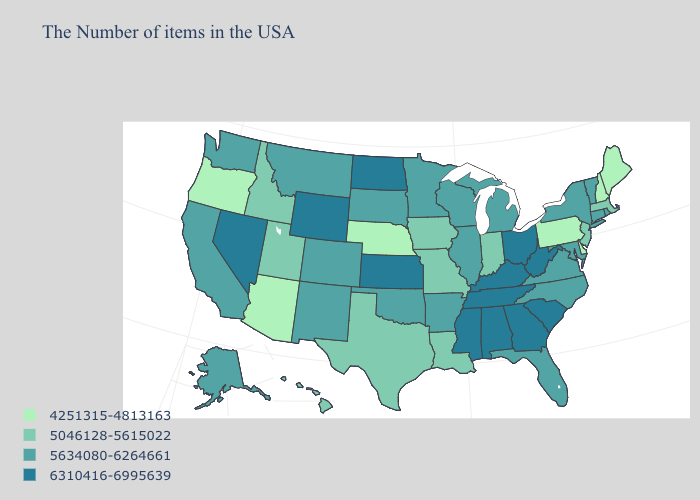Which states have the highest value in the USA?
Be succinct. South Carolina, West Virginia, Ohio, Georgia, Kentucky, Alabama, Tennessee, Mississippi, Kansas, North Dakota, Wyoming, Nevada. What is the value of Florida?
Quick response, please. 5634080-6264661. What is the highest value in the South ?
Keep it brief. 6310416-6995639. Among the states that border Arizona , does Nevada have the highest value?
Keep it brief. Yes. Name the states that have a value in the range 6310416-6995639?
Quick response, please. South Carolina, West Virginia, Ohio, Georgia, Kentucky, Alabama, Tennessee, Mississippi, Kansas, North Dakota, Wyoming, Nevada. How many symbols are there in the legend?
Answer briefly. 4. What is the value of Utah?
Give a very brief answer. 5046128-5615022. Does Vermont have the lowest value in the Northeast?
Be succinct. No. Which states have the highest value in the USA?
Be succinct. South Carolina, West Virginia, Ohio, Georgia, Kentucky, Alabama, Tennessee, Mississippi, Kansas, North Dakota, Wyoming, Nevada. Is the legend a continuous bar?
Quick response, please. No. What is the value of Illinois?
Keep it brief. 5634080-6264661. What is the highest value in the USA?
Keep it brief. 6310416-6995639. What is the lowest value in the South?
Answer briefly. 4251315-4813163. What is the value of Alaska?
Short answer required. 5634080-6264661. What is the value of Rhode Island?
Concise answer only. 5634080-6264661. 